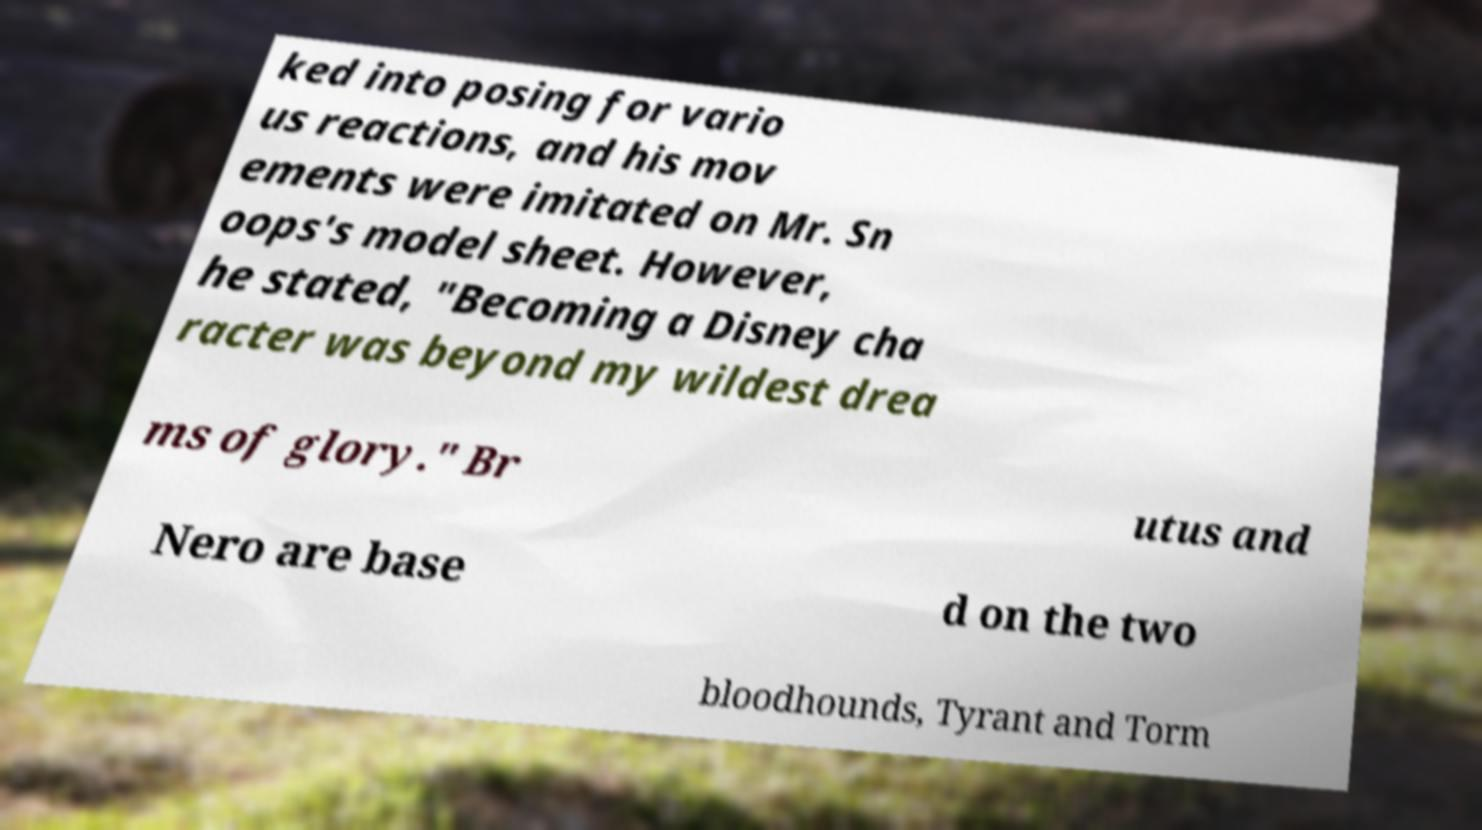What messages or text are displayed in this image? I need them in a readable, typed format. ked into posing for vario us reactions, and his mov ements were imitated on Mr. Sn oops's model sheet. However, he stated, "Becoming a Disney cha racter was beyond my wildest drea ms of glory." Br utus and Nero are base d on the two bloodhounds, Tyrant and Torm 